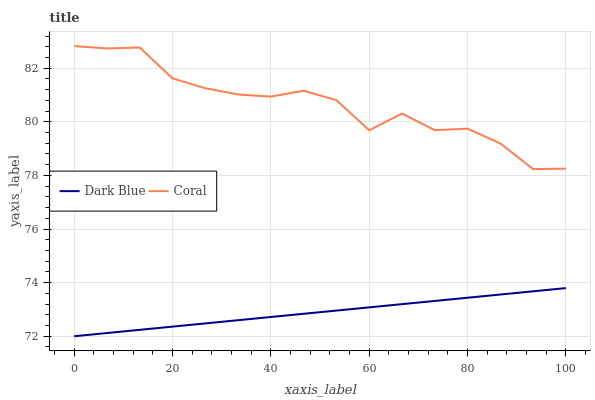Does Dark Blue have the minimum area under the curve?
Answer yes or no. Yes. Does Coral have the maximum area under the curve?
Answer yes or no. Yes. Does Coral have the minimum area under the curve?
Answer yes or no. No. Is Dark Blue the smoothest?
Answer yes or no. Yes. Is Coral the roughest?
Answer yes or no. Yes. Is Coral the smoothest?
Answer yes or no. No. Does Coral have the lowest value?
Answer yes or no. No. Does Coral have the highest value?
Answer yes or no. Yes. Is Dark Blue less than Coral?
Answer yes or no. Yes. Is Coral greater than Dark Blue?
Answer yes or no. Yes. Does Dark Blue intersect Coral?
Answer yes or no. No. 